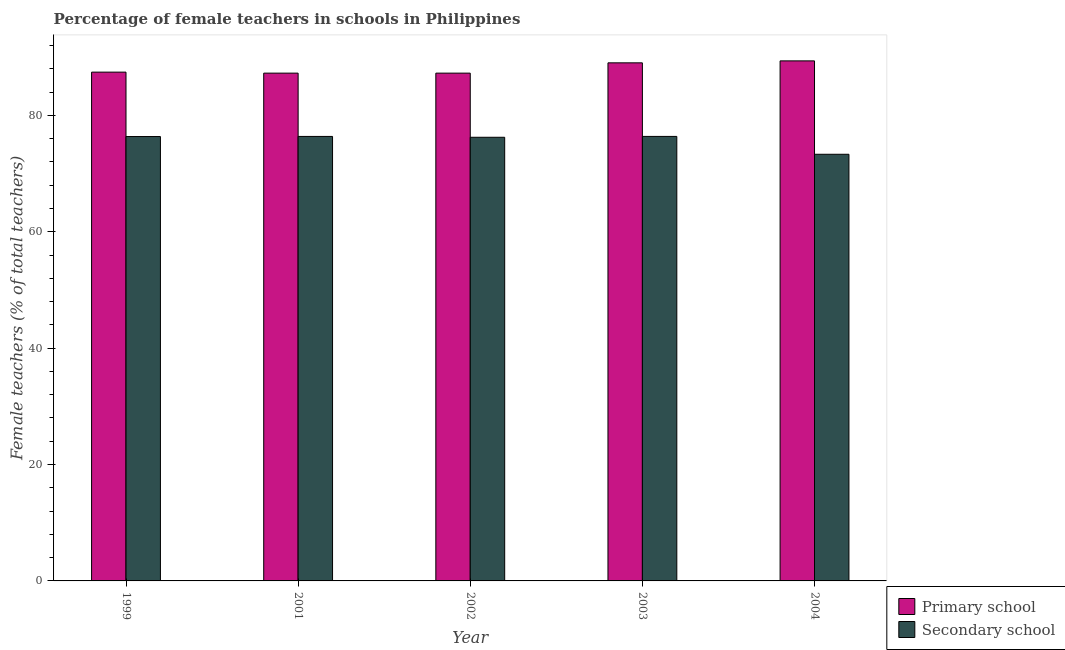How many different coloured bars are there?
Offer a very short reply. 2. How many bars are there on the 5th tick from the right?
Your response must be concise. 2. What is the label of the 4th group of bars from the left?
Your answer should be compact. 2003. What is the percentage of female teachers in primary schools in 2003?
Your answer should be compact. 89.02. Across all years, what is the maximum percentage of female teachers in secondary schools?
Provide a succinct answer. 76.38. Across all years, what is the minimum percentage of female teachers in primary schools?
Give a very brief answer. 87.25. In which year was the percentage of female teachers in secondary schools maximum?
Make the answer very short. 2003. In which year was the percentage of female teachers in secondary schools minimum?
Your response must be concise. 2004. What is the total percentage of female teachers in primary schools in the graph?
Keep it short and to the point. 440.31. What is the difference between the percentage of female teachers in secondary schools in 2001 and that in 2003?
Give a very brief answer. -0. What is the difference between the percentage of female teachers in secondary schools in 2003 and the percentage of female teachers in primary schools in 2004?
Make the answer very short. 3.07. What is the average percentage of female teachers in secondary schools per year?
Keep it short and to the point. 75.73. In how many years, is the percentage of female teachers in secondary schools greater than 20 %?
Your response must be concise. 5. What is the ratio of the percentage of female teachers in secondary schools in 1999 to that in 2002?
Offer a very short reply. 1. What is the difference between the highest and the second highest percentage of female teachers in secondary schools?
Provide a succinct answer. 0. What is the difference between the highest and the lowest percentage of female teachers in secondary schools?
Give a very brief answer. 3.07. In how many years, is the percentage of female teachers in secondary schools greater than the average percentage of female teachers in secondary schools taken over all years?
Make the answer very short. 4. What does the 1st bar from the left in 2001 represents?
Provide a short and direct response. Primary school. What does the 2nd bar from the right in 2004 represents?
Provide a short and direct response. Primary school. How many bars are there?
Provide a succinct answer. 10. What is the difference between two consecutive major ticks on the Y-axis?
Your response must be concise. 20. Are the values on the major ticks of Y-axis written in scientific E-notation?
Your answer should be very brief. No. Does the graph contain any zero values?
Provide a succinct answer. No. How are the legend labels stacked?
Ensure brevity in your answer.  Vertical. What is the title of the graph?
Offer a terse response. Percentage of female teachers in schools in Philippines. Does "Male labor force" appear as one of the legend labels in the graph?
Provide a short and direct response. No. What is the label or title of the X-axis?
Ensure brevity in your answer.  Year. What is the label or title of the Y-axis?
Provide a succinct answer. Female teachers (% of total teachers). What is the Female teachers (% of total teachers) in Primary school in 1999?
Provide a short and direct response. 87.42. What is the Female teachers (% of total teachers) of Secondary school in 1999?
Your answer should be compact. 76.36. What is the Female teachers (% of total teachers) of Primary school in 2001?
Offer a very short reply. 87.25. What is the Female teachers (% of total teachers) in Secondary school in 2001?
Your answer should be compact. 76.38. What is the Female teachers (% of total teachers) of Primary school in 2002?
Provide a short and direct response. 87.25. What is the Female teachers (% of total teachers) in Secondary school in 2002?
Make the answer very short. 76.23. What is the Female teachers (% of total teachers) in Primary school in 2003?
Ensure brevity in your answer.  89.02. What is the Female teachers (% of total teachers) in Secondary school in 2003?
Provide a succinct answer. 76.38. What is the Female teachers (% of total teachers) in Primary school in 2004?
Ensure brevity in your answer.  89.36. What is the Female teachers (% of total teachers) in Secondary school in 2004?
Your answer should be compact. 73.31. Across all years, what is the maximum Female teachers (% of total teachers) in Primary school?
Keep it short and to the point. 89.36. Across all years, what is the maximum Female teachers (% of total teachers) of Secondary school?
Provide a short and direct response. 76.38. Across all years, what is the minimum Female teachers (% of total teachers) in Primary school?
Offer a terse response. 87.25. Across all years, what is the minimum Female teachers (% of total teachers) of Secondary school?
Make the answer very short. 73.31. What is the total Female teachers (% of total teachers) in Primary school in the graph?
Offer a terse response. 440.31. What is the total Female teachers (% of total teachers) in Secondary school in the graph?
Make the answer very short. 378.66. What is the difference between the Female teachers (% of total teachers) in Primary school in 1999 and that in 2001?
Ensure brevity in your answer.  0.17. What is the difference between the Female teachers (% of total teachers) of Secondary school in 1999 and that in 2001?
Provide a short and direct response. -0.02. What is the difference between the Female teachers (% of total teachers) in Primary school in 1999 and that in 2002?
Your answer should be compact. 0.17. What is the difference between the Female teachers (% of total teachers) of Primary school in 1999 and that in 2003?
Offer a terse response. -1.6. What is the difference between the Female teachers (% of total teachers) in Secondary school in 1999 and that in 2003?
Your answer should be very brief. -0.02. What is the difference between the Female teachers (% of total teachers) in Primary school in 1999 and that in 2004?
Give a very brief answer. -1.93. What is the difference between the Female teachers (% of total teachers) of Secondary school in 1999 and that in 2004?
Ensure brevity in your answer.  3.05. What is the difference between the Female teachers (% of total teachers) in Primary school in 2001 and that in 2002?
Offer a terse response. 0. What is the difference between the Female teachers (% of total teachers) of Secondary school in 2001 and that in 2002?
Keep it short and to the point. 0.15. What is the difference between the Female teachers (% of total teachers) of Primary school in 2001 and that in 2003?
Your answer should be very brief. -1.77. What is the difference between the Female teachers (% of total teachers) in Secondary school in 2001 and that in 2003?
Make the answer very short. -0. What is the difference between the Female teachers (% of total teachers) of Primary school in 2001 and that in 2004?
Your answer should be compact. -2.11. What is the difference between the Female teachers (% of total teachers) of Secondary school in 2001 and that in 2004?
Keep it short and to the point. 3.07. What is the difference between the Female teachers (% of total teachers) in Primary school in 2002 and that in 2003?
Give a very brief answer. -1.77. What is the difference between the Female teachers (% of total teachers) of Secondary school in 2002 and that in 2003?
Your response must be concise. -0.15. What is the difference between the Female teachers (% of total teachers) in Primary school in 2002 and that in 2004?
Your response must be concise. -2.11. What is the difference between the Female teachers (% of total teachers) in Secondary school in 2002 and that in 2004?
Give a very brief answer. 2.92. What is the difference between the Female teachers (% of total teachers) in Primary school in 2003 and that in 2004?
Provide a succinct answer. -0.34. What is the difference between the Female teachers (% of total teachers) in Secondary school in 2003 and that in 2004?
Offer a terse response. 3.07. What is the difference between the Female teachers (% of total teachers) of Primary school in 1999 and the Female teachers (% of total teachers) of Secondary school in 2001?
Offer a very short reply. 11.05. What is the difference between the Female teachers (% of total teachers) of Primary school in 1999 and the Female teachers (% of total teachers) of Secondary school in 2002?
Provide a succinct answer. 11.19. What is the difference between the Female teachers (% of total teachers) in Primary school in 1999 and the Female teachers (% of total teachers) in Secondary school in 2003?
Your response must be concise. 11.05. What is the difference between the Female teachers (% of total teachers) of Primary school in 1999 and the Female teachers (% of total teachers) of Secondary school in 2004?
Your answer should be compact. 14.11. What is the difference between the Female teachers (% of total teachers) of Primary school in 2001 and the Female teachers (% of total teachers) of Secondary school in 2002?
Your response must be concise. 11.02. What is the difference between the Female teachers (% of total teachers) of Primary school in 2001 and the Female teachers (% of total teachers) of Secondary school in 2003?
Ensure brevity in your answer.  10.87. What is the difference between the Female teachers (% of total teachers) of Primary school in 2001 and the Female teachers (% of total teachers) of Secondary school in 2004?
Ensure brevity in your answer.  13.94. What is the difference between the Female teachers (% of total teachers) of Primary school in 2002 and the Female teachers (% of total teachers) of Secondary school in 2003?
Provide a succinct answer. 10.87. What is the difference between the Female teachers (% of total teachers) of Primary school in 2002 and the Female teachers (% of total teachers) of Secondary school in 2004?
Make the answer very short. 13.94. What is the difference between the Female teachers (% of total teachers) of Primary school in 2003 and the Female teachers (% of total teachers) of Secondary school in 2004?
Ensure brevity in your answer.  15.71. What is the average Female teachers (% of total teachers) in Primary school per year?
Offer a terse response. 88.06. What is the average Female teachers (% of total teachers) of Secondary school per year?
Your answer should be compact. 75.73. In the year 1999, what is the difference between the Female teachers (% of total teachers) of Primary school and Female teachers (% of total teachers) of Secondary school?
Offer a very short reply. 11.07. In the year 2001, what is the difference between the Female teachers (% of total teachers) in Primary school and Female teachers (% of total teachers) in Secondary school?
Offer a very short reply. 10.87. In the year 2002, what is the difference between the Female teachers (% of total teachers) in Primary school and Female teachers (% of total teachers) in Secondary school?
Offer a very short reply. 11.02. In the year 2003, what is the difference between the Female teachers (% of total teachers) of Primary school and Female teachers (% of total teachers) of Secondary school?
Make the answer very short. 12.64. In the year 2004, what is the difference between the Female teachers (% of total teachers) of Primary school and Female teachers (% of total teachers) of Secondary school?
Make the answer very short. 16.05. What is the ratio of the Female teachers (% of total teachers) in Secondary school in 1999 to that in 2001?
Your answer should be compact. 1. What is the ratio of the Female teachers (% of total teachers) in Primary school in 1999 to that in 2002?
Ensure brevity in your answer.  1. What is the ratio of the Female teachers (% of total teachers) of Secondary school in 1999 to that in 2002?
Make the answer very short. 1. What is the ratio of the Female teachers (% of total teachers) in Primary school in 1999 to that in 2003?
Provide a short and direct response. 0.98. What is the ratio of the Female teachers (% of total teachers) in Primary school in 1999 to that in 2004?
Provide a short and direct response. 0.98. What is the ratio of the Female teachers (% of total teachers) in Secondary school in 1999 to that in 2004?
Ensure brevity in your answer.  1.04. What is the ratio of the Female teachers (% of total teachers) of Secondary school in 2001 to that in 2002?
Give a very brief answer. 1. What is the ratio of the Female teachers (% of total teachers) in Primary school in 2001 to that in 2003?
Your response must be concise. 0.98. What is the ratio of the Female teachers (% of total teachers) in Secondary school in 2001 to that in 2003?
Make the answer very short. 1. What is the ratio of the Female teachers (% of total teachers) in Primary school in 2001 to that in 2004?
Keep it short and to the point. 0.98. What is the ratio of the Female teachers (% of total teachers) in Secondary school in 2001 to that in 2004?
Give a very brief answer. 1.04. What is the ratio of the Female teachers (% of total teachers) in Primary school in 2002 to that in 2003?
Your answer should be very brief. 0.98. What is the ratio of the Female teachers (% of total teachers) in Primary school in 2002 to that in 2004?
Offer a terse response. 0.98. What is the ratio of the Female teachers (% of total teachers) of Secondary school in 2002 to that in 2004?
Your response must be concise. 1.04. What is the ratio of the Female teachers (% of total teachers) in Primary school in 2003 to that in 2004?
Your answer should be compact. 1. What is the ratio of the Female teachers (% of total teachers) in Secondary school in 2003 to that in 2004?
Make the answer very short. 1.04. What is the difference between the highest and the second highest Female teachers (% of total teachers) of Primary school?
Provide a succinct answer. 0.34. What is the difference between the highest and the lowest Female teachers (% of total teachers) of Primary school?
Make the answer very short. 2.11. What is the difference between the highest and the lowest Female teachers (% of total teachers) of Secondary school?
Your response must be concise. 3.07. 